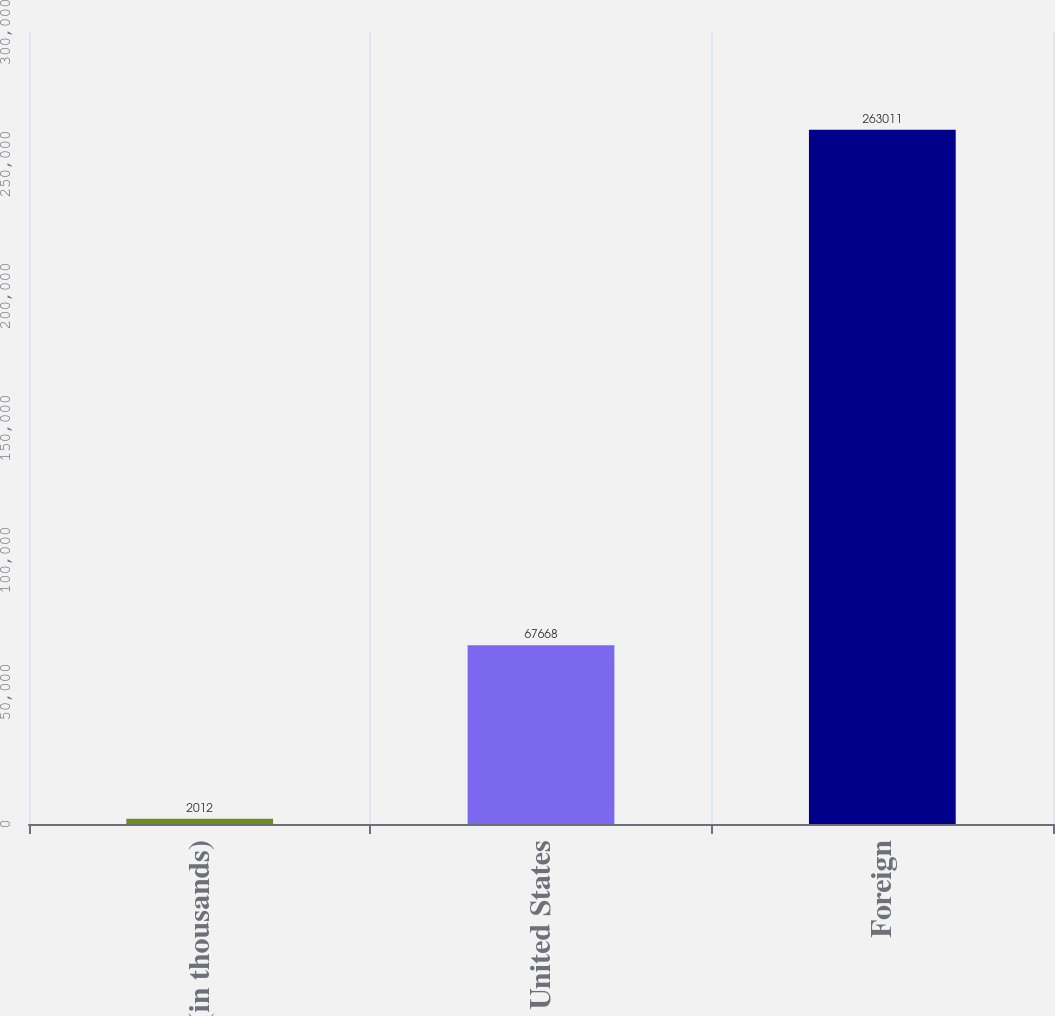Convert chart to OTSL. <chart><loc_0><loc_0><loc_500><loc_500><bar_chart><fcel>(in thousands)<fcel>United States<fcel>Foreign<nl><fcel>2012<fcel>67668<fcel>263011<nl></chart> 